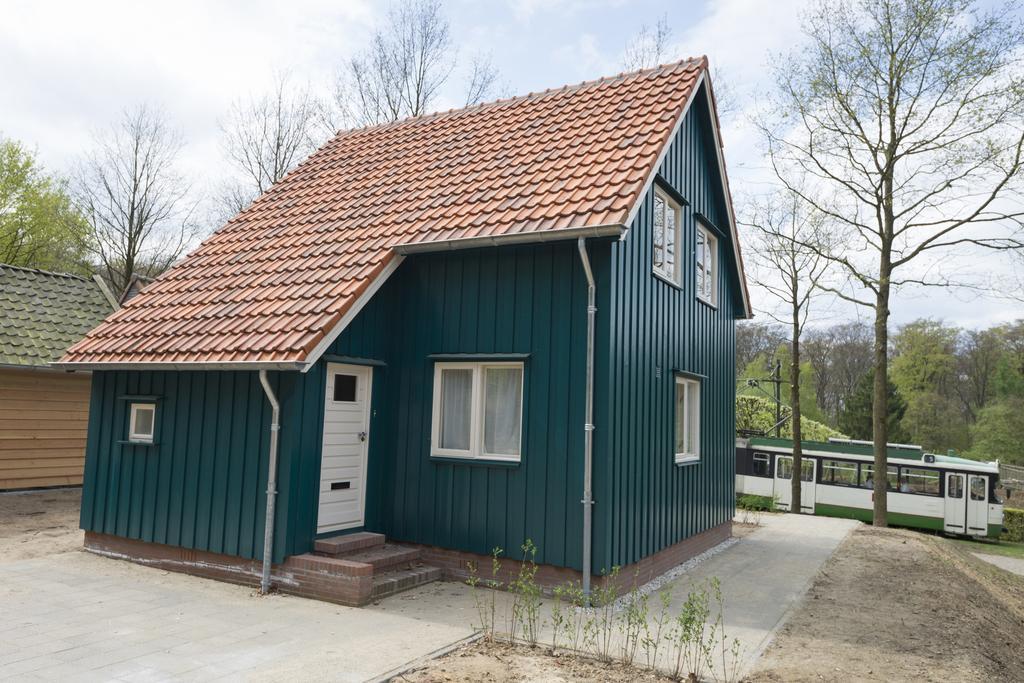How would you summarize this image in a sentence or two? In this image in the center there is home. In the background there is bus and there are trees and the sky is cloudy. On the left side there is hut. 